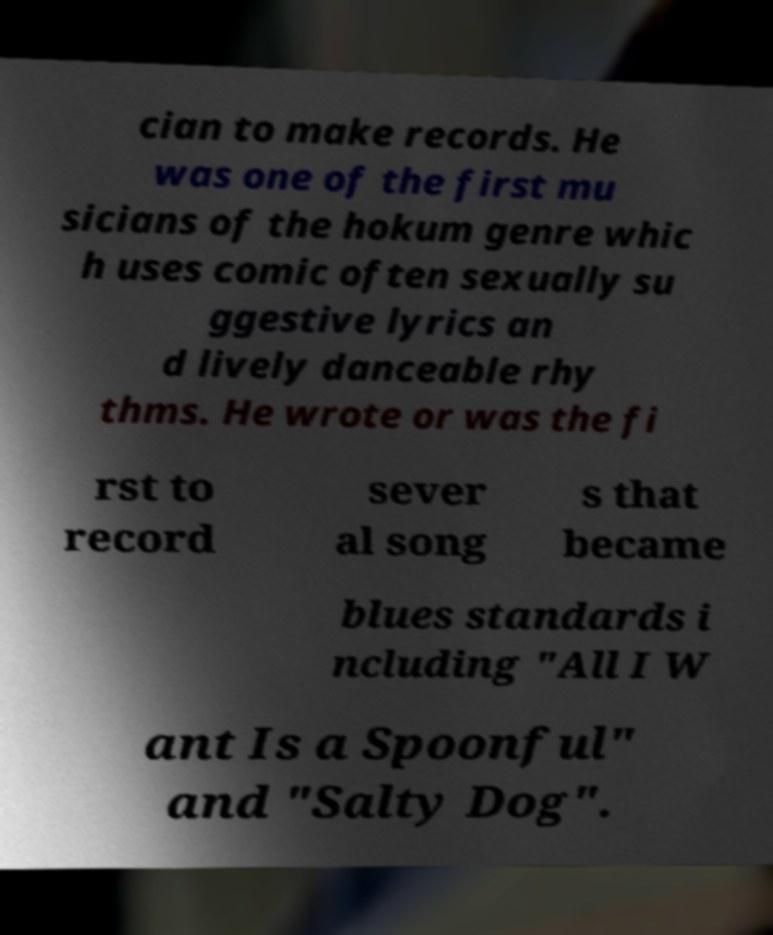Please identify and transcribe the text found in this image. cian to make records. He was one of the first mu sicians of the hokum genre whic h uses comic often sexually su ggestive lyrics an d lively danceable rhy thms. He wrote or was the fi rst to record sever al song s that became blues standards i ncluding "All I W ant Is a Spoonful" and "Salty Dog". 